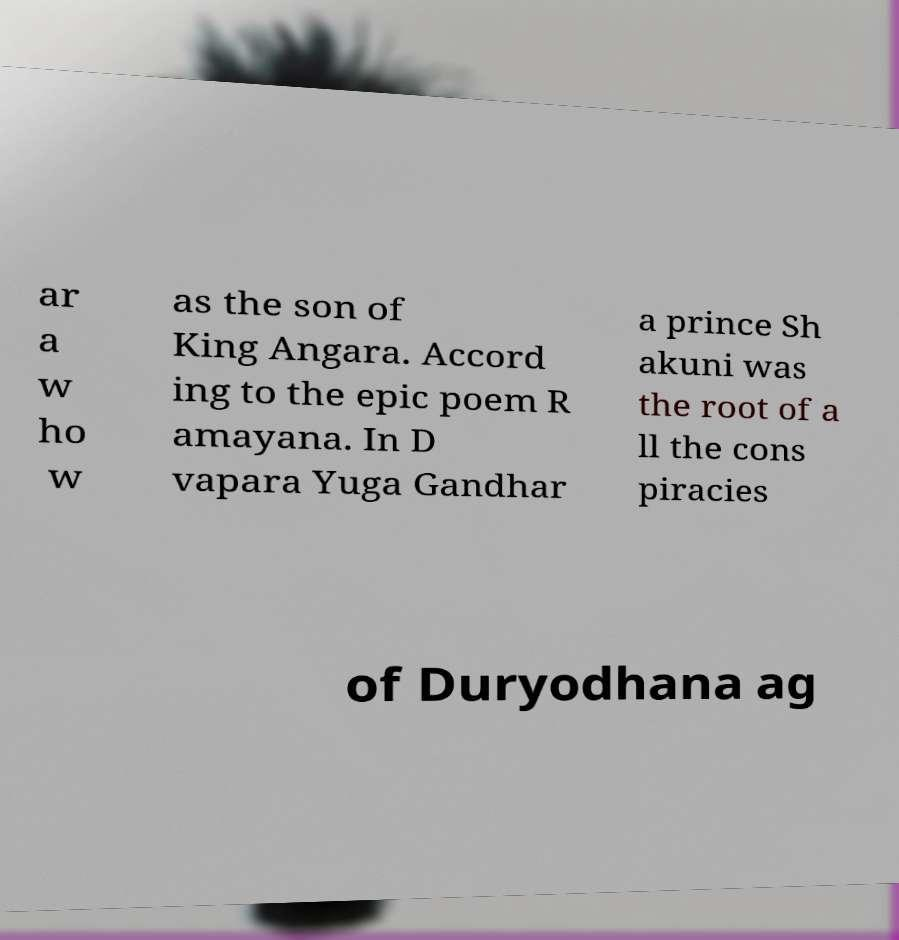For documentation purposes, I need the text within this image transcribed. Could you provide that? ar a w ho w as the son of King Angara. Accord ing to the epic poem R amayana. In D vapara Yuga Gandhar a prince Sh akuni was the root of a ll the cons piracies of Duryodhana ag 